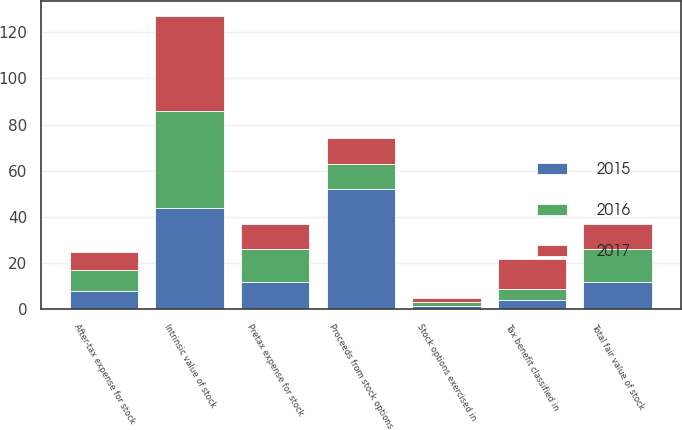Convert chart. <chart><loc_0><loc_0><loc_500><loc_500><stacked_bar_chart><ecel><fcel>Pretax expense for stock<fcel>After-tax expense for stock<fcel>Proceeds from stock options<fcel>Tax benefit classified in<fcel>Intrinsic value of stock<fcel>Total fair value of stock<fcel>Stock options exercised in<nl><fcel>2017<fcel>11<fcel>8<fcel>11<fcel>13<fcel>41<fcel>11<fcel>1.5<nl><fcel>2016<fcel>14<fcel>9<fcel>11<fcel>5<fcel>42<fcel>14<fcel>1.9<nl><fcel>2015<fcel>12<fcel>8<fcel>52<fcel>4<fcel>44<fcel>12<fcel>1.4<nl></chart> 